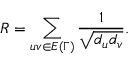Convert formula to latex. <formula><loc_0><loc_0><loc_500><loc_500>R = \sum _ { u v \in E { ( \Gamma ) } } \frac { 1 } { \sqrt { d _ { u } d _ { v } } } .</formula> 